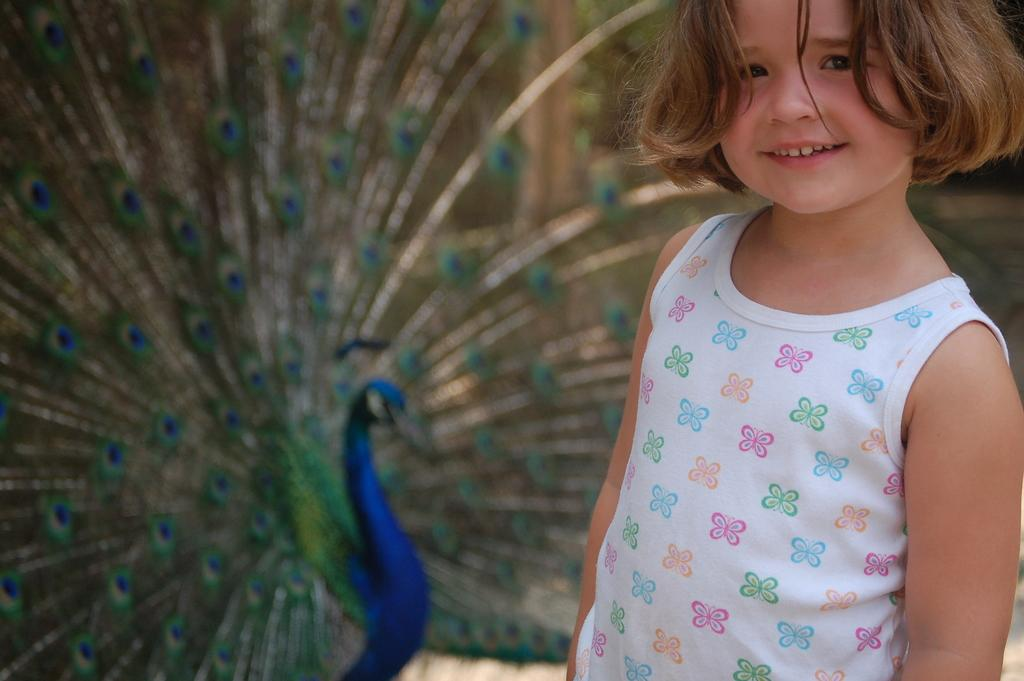Who is present in the image? There is a girl in the image. Where is the girl located in the image? The girl is standing on the right side of the image. What expression does the girl have? The girl is smiling. What can be seen in the background of the image? There is a peacock in the background of the image. What type of underwear is the girl wearing in the image? There is no information about the girl's underwear in the image, so it cannot be determined. 